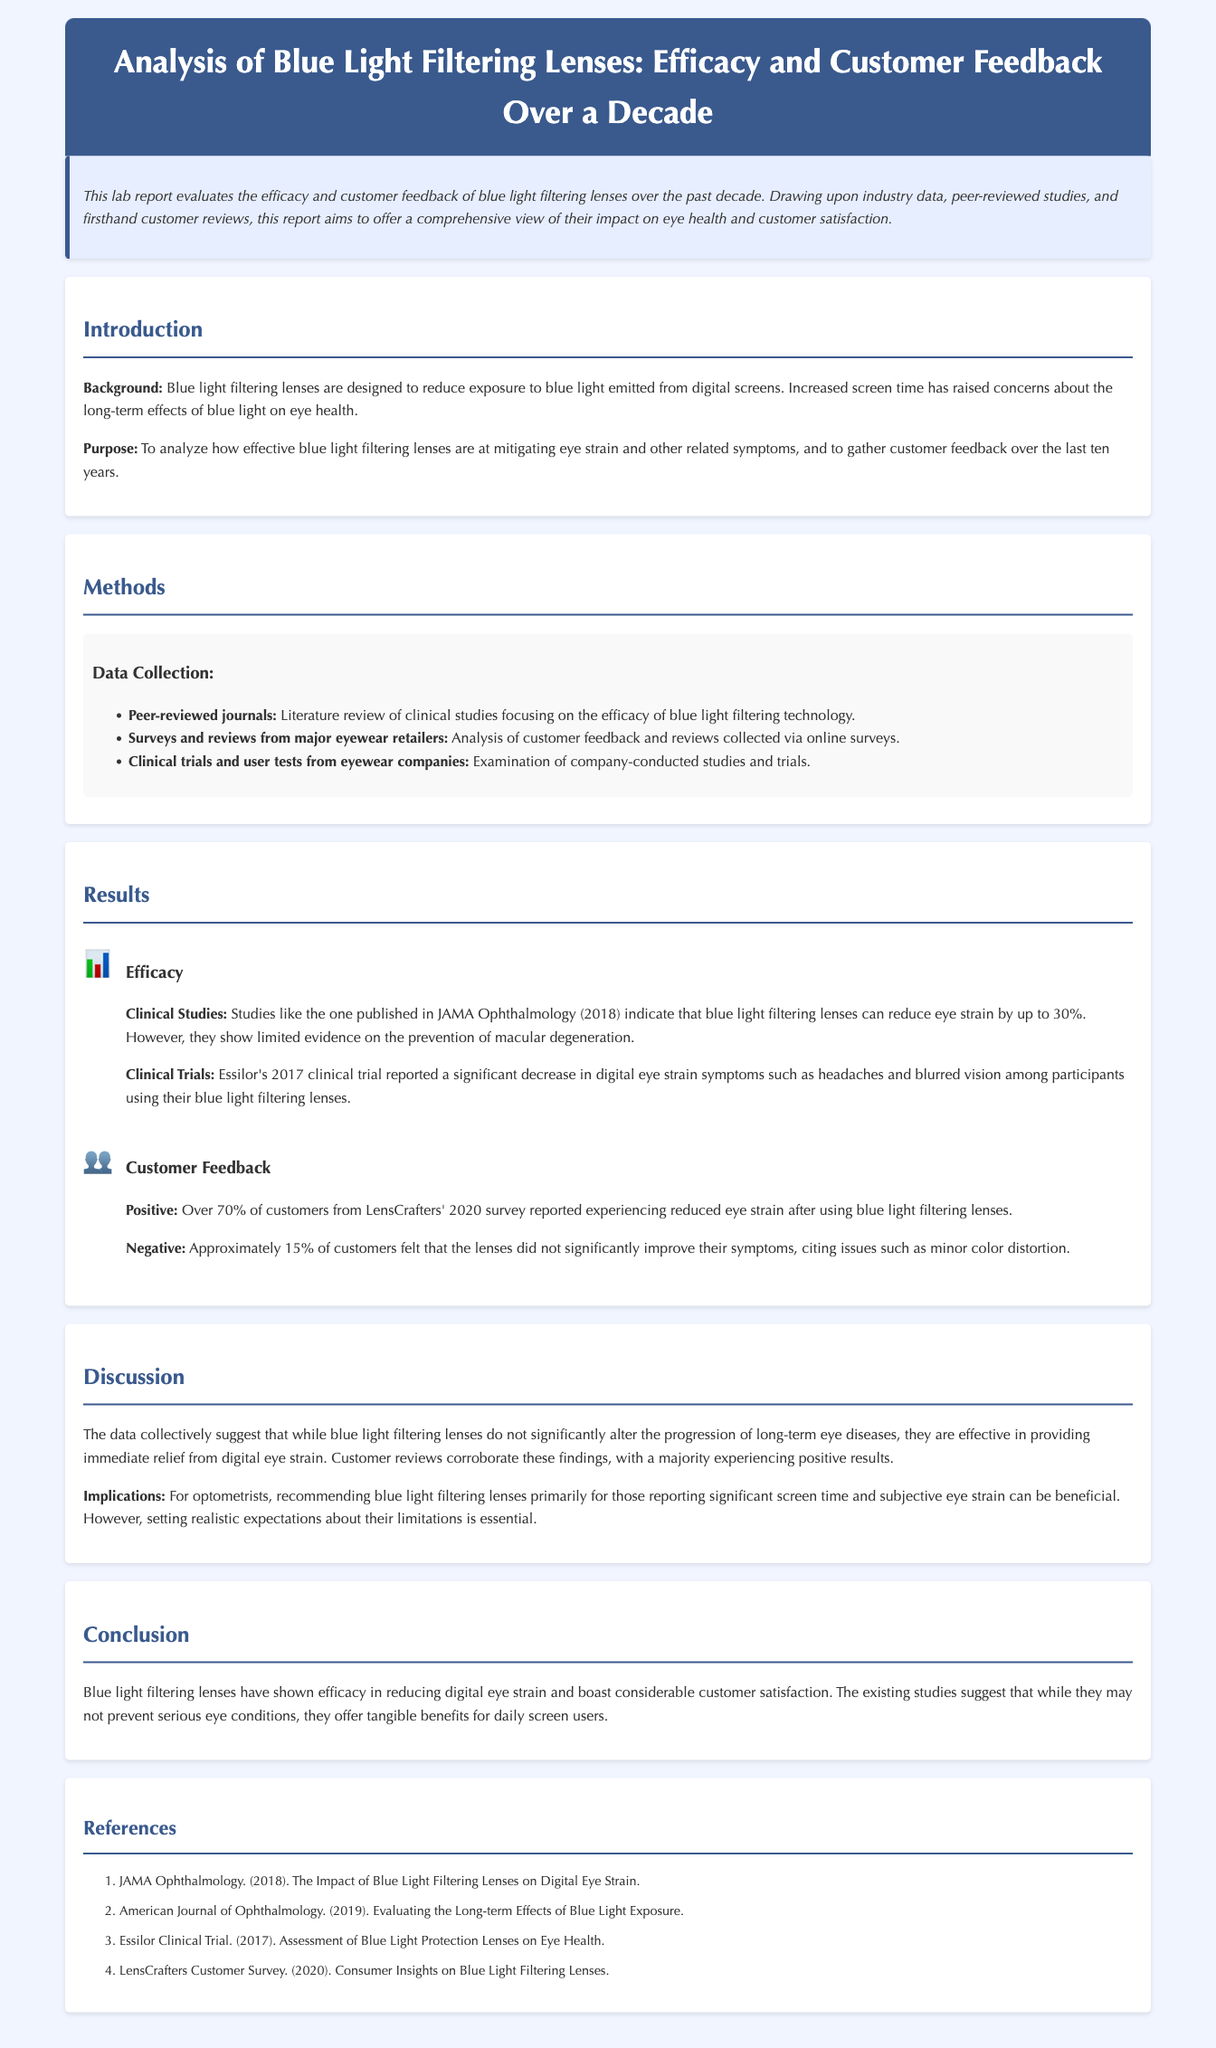What is the main focus of the lab report? The main focus of the lab report is to evaluate the efficacy and customer feedback of blue light filtering lenses over the past decade.
Answer: Efficacy and customer feedback of blue light filtering lenses How much can blue light filtering lenses reduce eye strain according to clinical studies? Clinical studies indicate that blue light filtering lenses can reduce eye strain by up to 30%.
Answer: 30% What percentage of customers reported reduced eye strain after using blue light filtering lenses in the 2020 survey? According to the 2020 survey, over 70% of customers reported experiencing reduced eye strain after using blue light filtering lenses.
Answer: Over 70% What issue did approximately 15% of customers experience with blue light filtering lenses? Approximately 15% of customers felt that the lenses did not significantly improve their symptoms, citing issues such as minor color distortion.
Answer: Minor color distortion Which journal published a study related to the impact of blue light filtering lenses on digital eye strain? The study related to the impact of blue light filtering lenses on digital eye strain was published in JAMA Ophthalmology.
Answer: JAMA Ophthalmology What is one implication for optometrists mentioned in the discussion? One implication for optometrists is to recommend blue light filtering lenses primarily for those reporting significant screen time and subjective eye strain.
Answer: Recommend for significant screen time and subjective eye strain What year did Essilor conduct a clinical trial on blue light protection lenses? Essilor conducted a clinical trial on blue light protection lenses in 2017.
Answer: 2017 What percentage of customers did not find significant improvement from the lenses? Approximately 15% of customers felt that the lenses did not significantly improve their symptoms.
Answer: 15% What was the conclusion about the efficacy of blue light filtering lenses? The conclusion is that blue light filtering lenses have shown efficacy in reducing digital eye strain and boast considerable customer satisfaction.
Answer: Efficacy in reducing digital eye strain and considerable customer satisfaction 